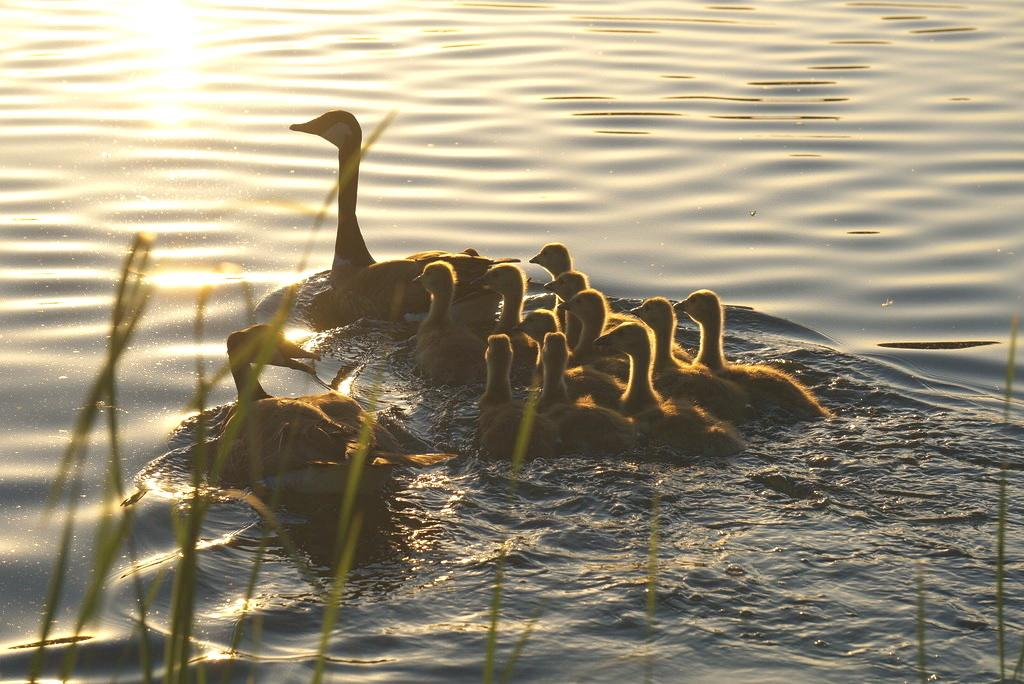What animals can be seen in the image? There are ducks in the image. What are the ducks doing in the image? The ducks are swimming in the water. What type of environment is visible in the image? There is grass visible in the image. How many toes can be seen on the ducks in the image? Ducks do not have toes like humans, so it is not possible to count toes on the ducks in the image. 